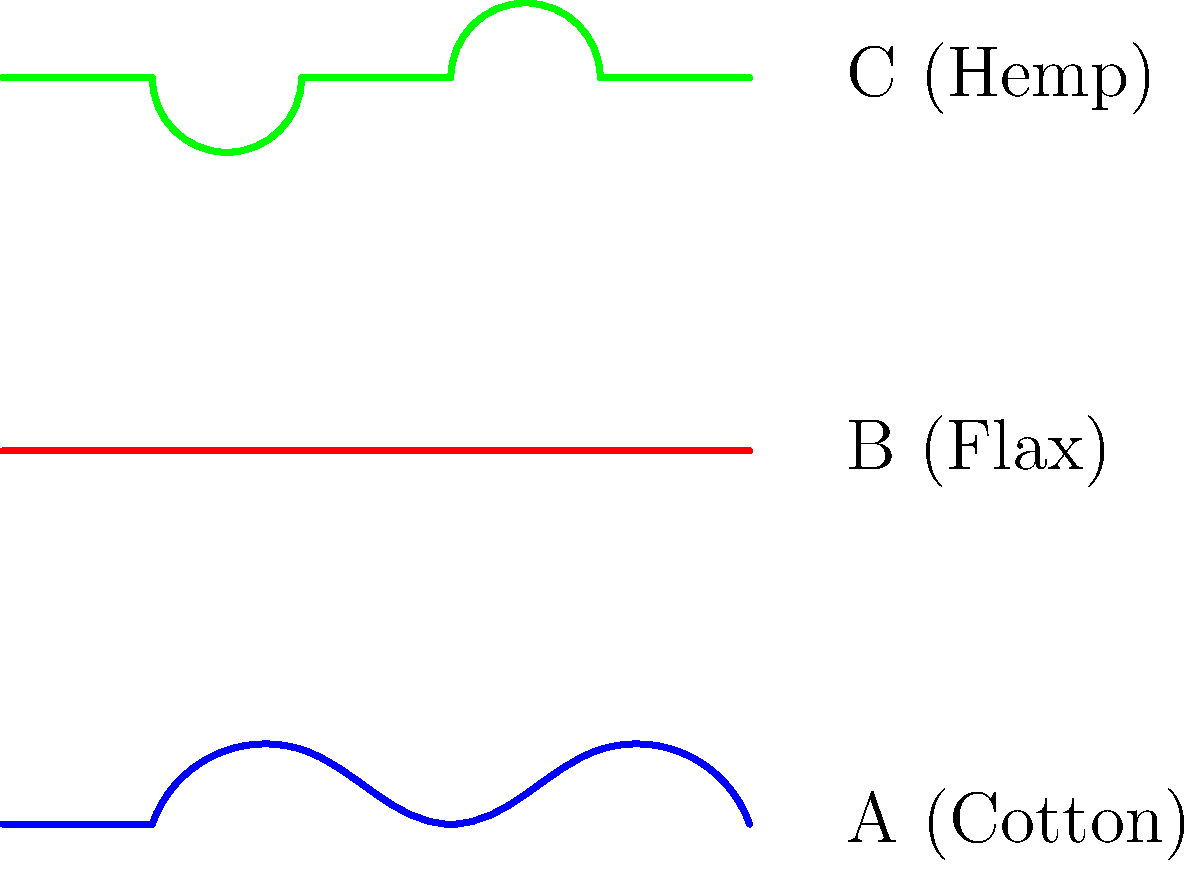Based on the microscopic cell structure diagrams of three different plant fibers shown above, which fiber would be most suitable for creating strong, durable textiles with minimal processing? To answer this question, we need to analyze the cell structures of the three plant fibers shown in the diagram:

1. Fiber A (Cotton): 
   - Has a twisted, ribbon-like structure
   - This structure provides softness but less strength

2. Fiber B (Flax):
   - Has a straight, smooth structure with minimal twists or bends
   - This structure indicates long, strong fibers that can be easily aligned

3. Fiber C (Hemp):
   - Has a slightly wavy structure with some bends
   - This structure suggests strength but may require more processing to align fibers

Considering the characteristics:
- Flax (Fiber B) has the straightest and most uniform structure
- Straight fibers are easier to align during processing
- Aligned fibers create stronger, more durable textiles
- Flax requires minimal processing to maintain its natural strength

Therefore, Fiber B (Flax) would be the most suitable for creating strong, durable textiles with minimal processing.
Answer: Flax (Fiber B) 